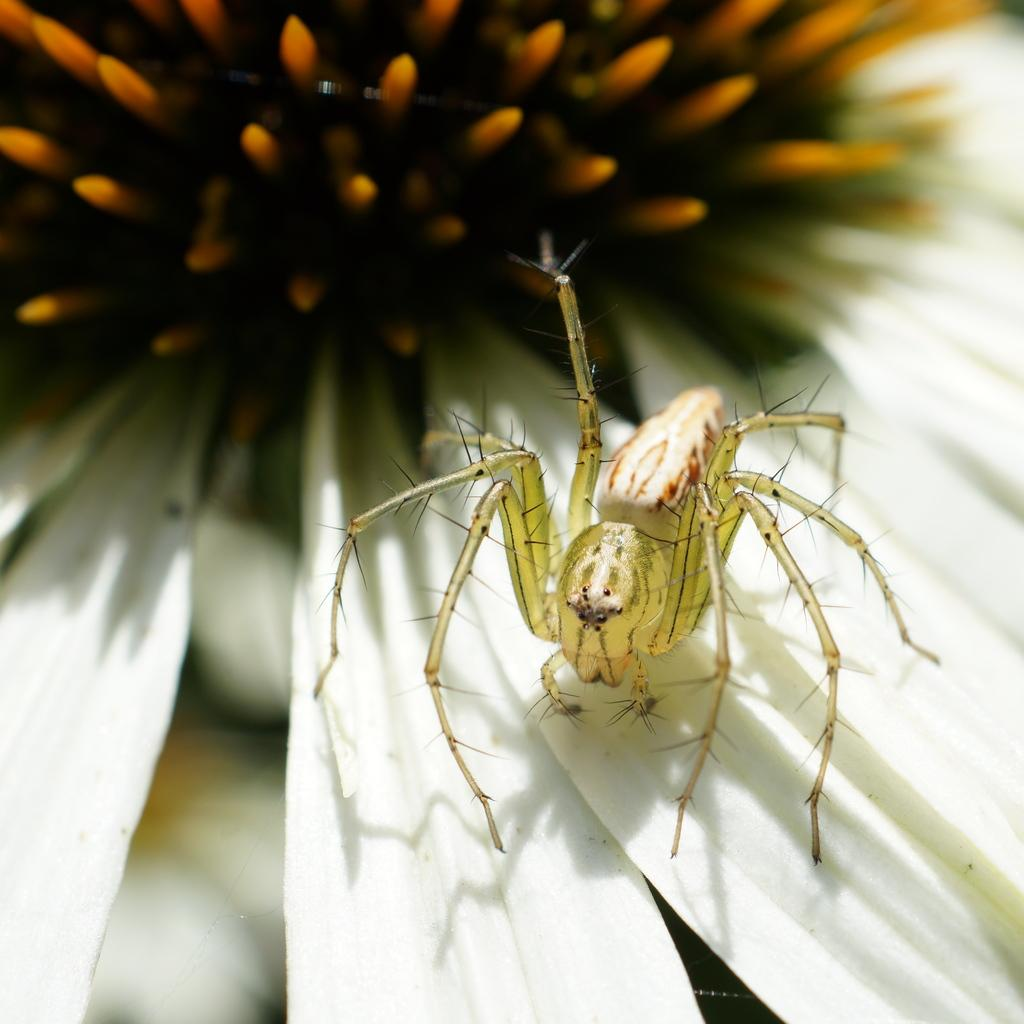What type of creature is present in the image? There is an insect in the image. Where is the insect located? The insect is on a flower. What type of seat can be seen in the image? There is no seat present in the image; it features an insect on a flower. What type of vessel is being used by the insect in the image? There is no vessel present in the image; it features an insect on a flower. 